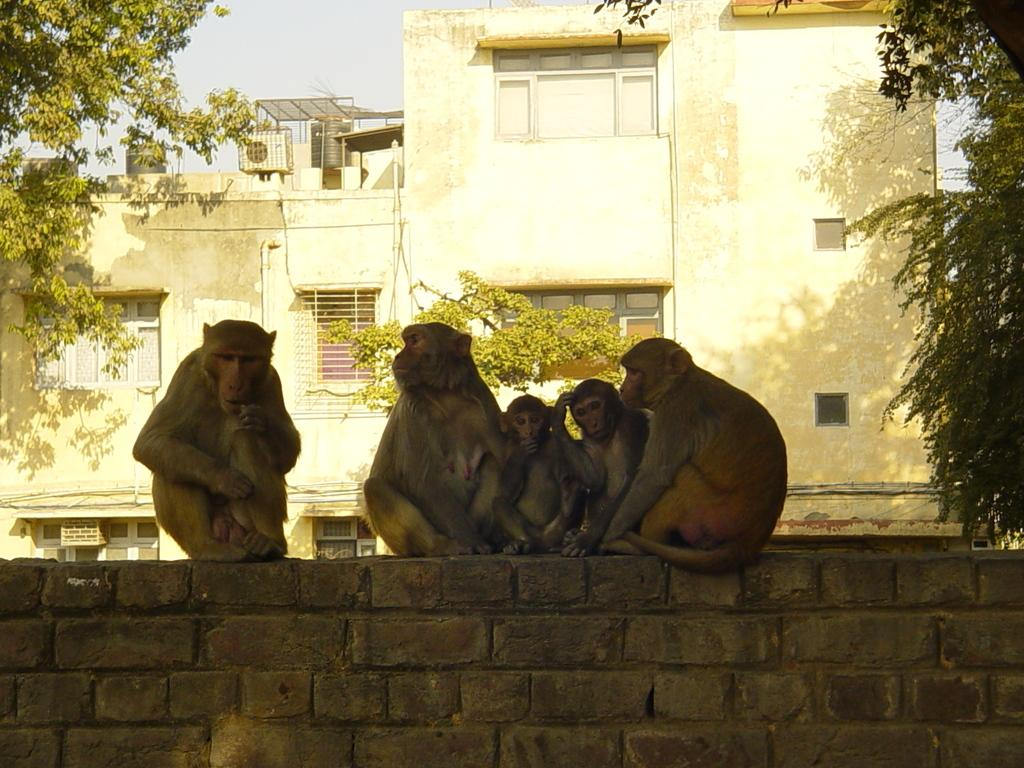What animals are in the image? There is a group of monkeys in the image. Where are the monkeys sitting? The monkeys are sitting on a wall. What can be seen in the background of the image? There are buildings, trees, overhead tanks, air conditioners, and the sky visible in the background of the image. What type of hole can be seen in the image? There is no hole present in the image. How many balls are being held by the monkeys in the image? There are no balls present in the image. 